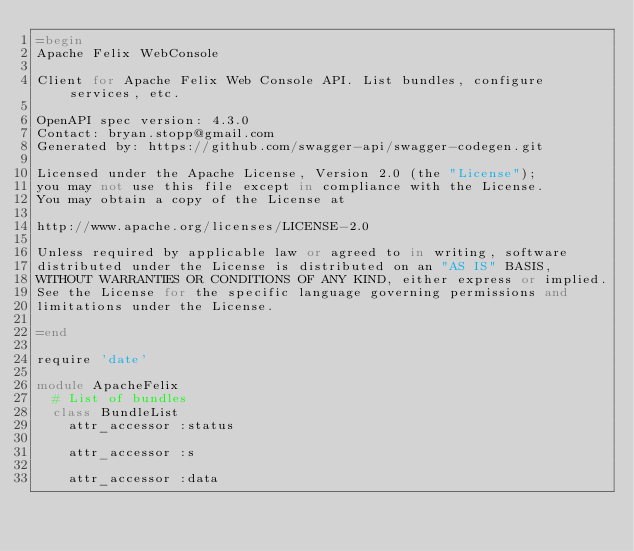<code> <loc_0><loc_0><loc_500><loc_500><_Ruby_>=begin
Apache Felix WebConsole

Client for Apache Felix Web Console API. List bundles, configure services, etc.

OpenAPI spec version: 4.3.0
Contact: bryan.stopp@gmail.com
Generated by: https://github.com/swagger-api/swagger-codegen.git

Licensed under the Apache License, Version 2.0 (the "License");
you may not use this file except in compliance with the License.
You may obtain a copy of the License at

http://www.apache.org/licenses/LICENSE-2.0

Unless required by applicable law or agreed to in writing, software
distributed under the License is distributed on an "AS IS" BASIS,
WITHOUT WARRANTIES OR CONDITIONS OF ANY KIND, either express or implied.
See the License for the specific language governing permissions and
limitations under the License.

=end

require 'date'

module ApacheFelix
  # List of bundles
  class BundleList
    attr_accessor :status

    attr_accessor :s

    attr_accessor :data

</code> 